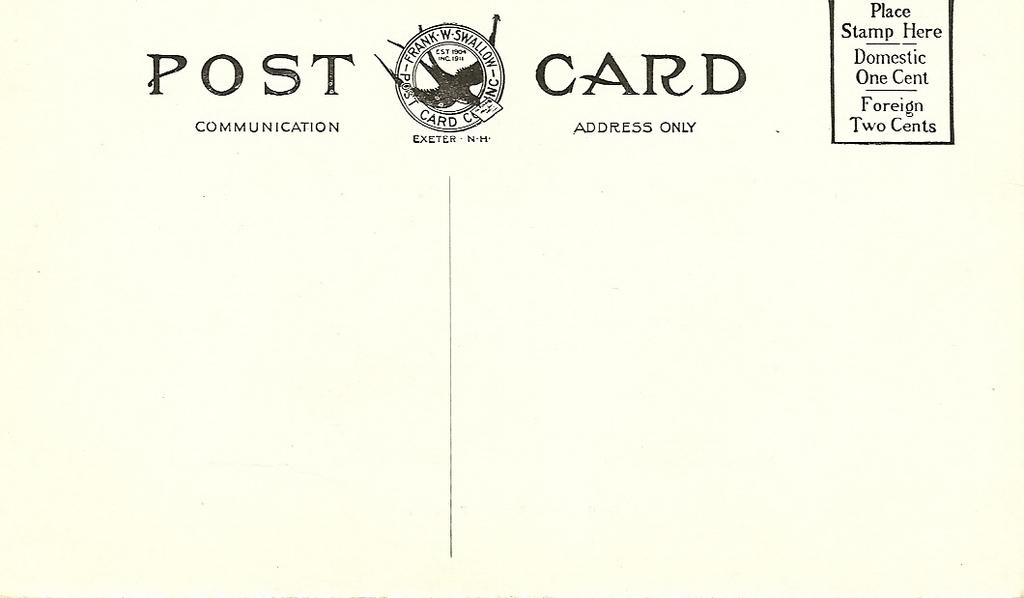<image>
Offer a succinct explanation of the picture presented. Postcard that says that Stamps should be placed on the top right. 